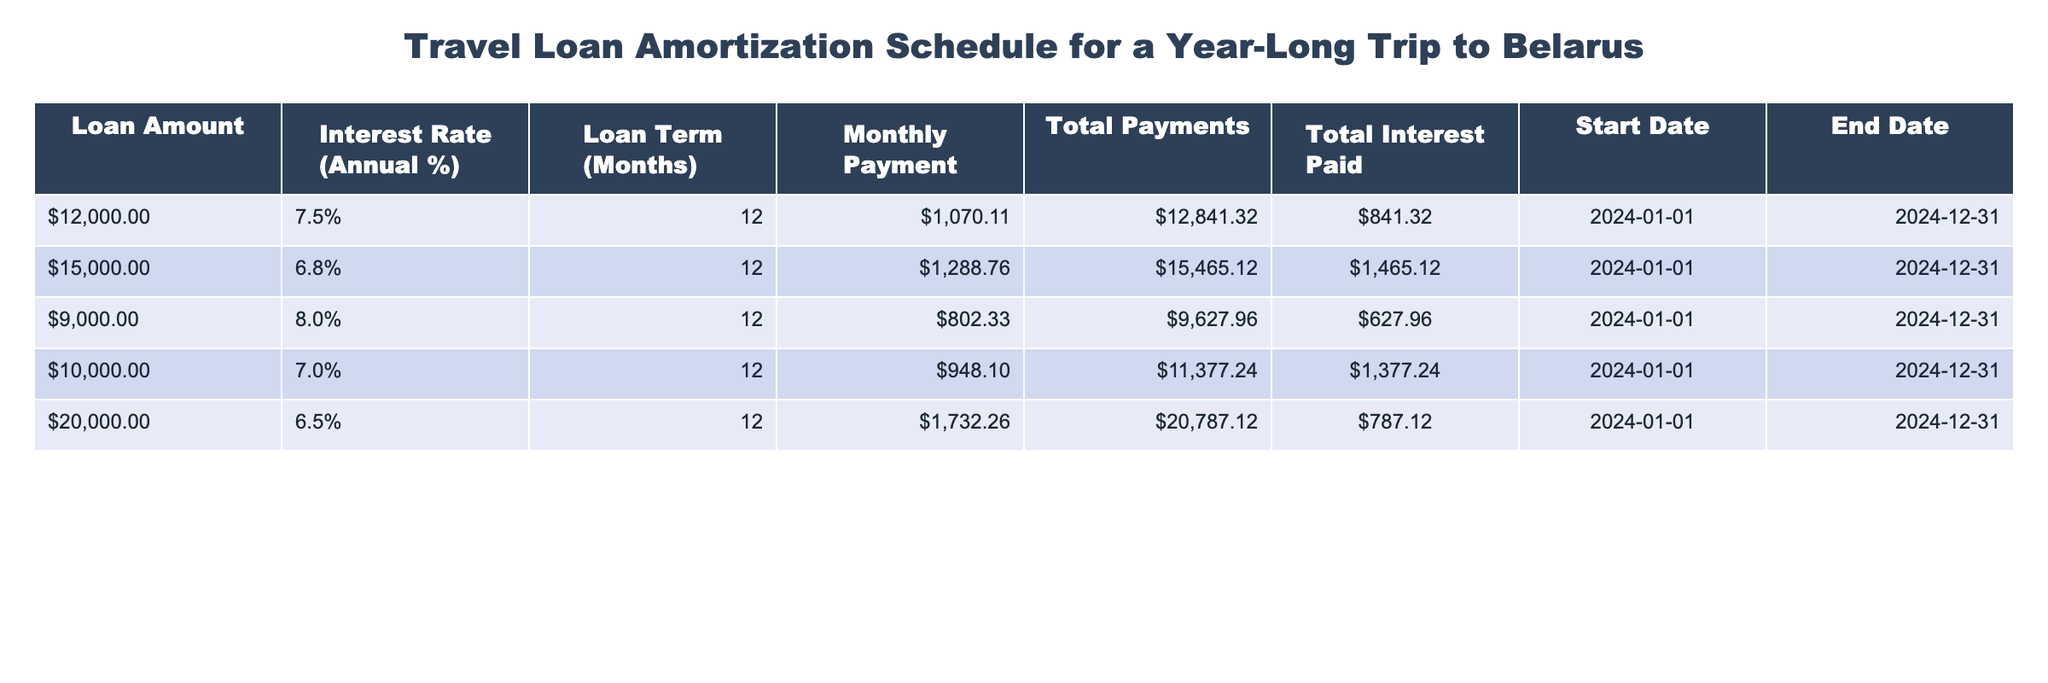What is the total interest paid for the loan of $20,000? Looking at the row for the loan amount of $20,000, the total interest paid is directly listed as $787.12.
Answer: $787.12 Which loan amount has the highest monthly payment? By comparing the monthly payment figures from all the loans, the loan amount of $20,000 has the highest monthly payment of $1,732.26, which is greater than all other amounts listed.
Answer: $20,000 Is the total payments for a $9,000 loan more than the total payments for a $12,000 loan? The total payments for the $9,000 loan is $9,627.96 and for the $12,000 loan is $12,841.32. Since $9,627.96 is less than $12,841.32, the statement is false.
Answer: No What is the difference in total interest paid between a $15,000 loan and a $10,000 loan? The total interest paid for the $15,000 loan is $1,465.12 and for the $10,000 loan it is $1,377.24. The difference is calculated as $1,465.12 - $1,377.24 = $87.88.
Answer: $87.88 What is the average monthly payment for all loans listed? To find the average monthly payment, add all monthly payments: $1,070.11 + $1,288.76 + $802.33 + $948.10 + $1,732.26 = $5,841.56. Then, divide by the number of loans (5), resulting in $5,841.56 / 5 = $1,168.31.
Answer: $1,168.31 